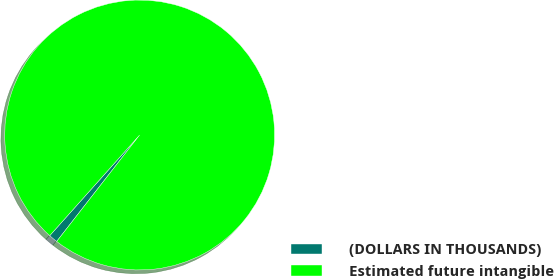Convert chart. <chart><loc_0><loc_0><loc_500><loc_500><pie_chart><fcel>(DOLLARS IN THOUSANDS)<fcel>Estimated future intangible<nl><fcel>1.07%<fcel>98.93%<nl></chart> 